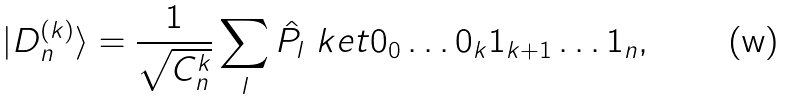Convert formula to latex. <formula><loc_0><loc_0><loc_500><loc_500>| D ^ { ( k ) } _ { n } \rangle = \frac { 1 } { \sqrt { C ^ { k } _ { n } } } \sum _ { l } \hat { P } _ { l } \ k e t { 0 _ { 0 } \dots 0 _ { k } 1 _ { k + 1 } \dots 1 _ { n } } ,</formula> 